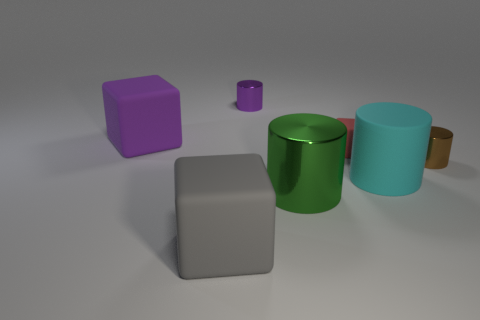Subtract all big matte cylinders. How many cylinders are left? 3 Subtract all purple cubes. How many cubes are left? 2 Add 3 small red rubber cubes. How many objects exist? 10 Subtract all cylinders. How many objects are left? 3 Subtract 2 blocks. How many blocks are left? 1 Subtract all brown cubes. How many brown cylinders are left? 1 Subtract all big cyan rubber cylinders. Subtract all green objects. How many objects are left? 5 Add 1 large metallic things. How many large metallic things are left? 2 Add 5 brown objects. How many brown objects exist? 6 Subtract 0 green cubes. How many objects are left? 7 